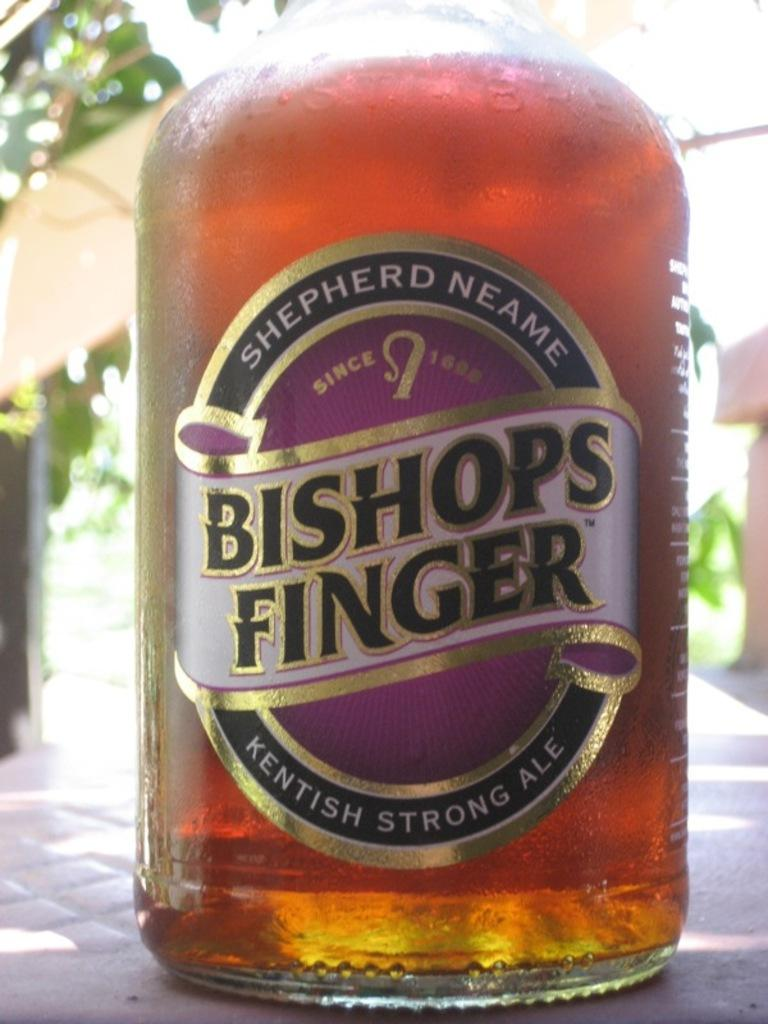<image>
Share a concise interpretation of the image provided. a Bishops glass that is on a table 